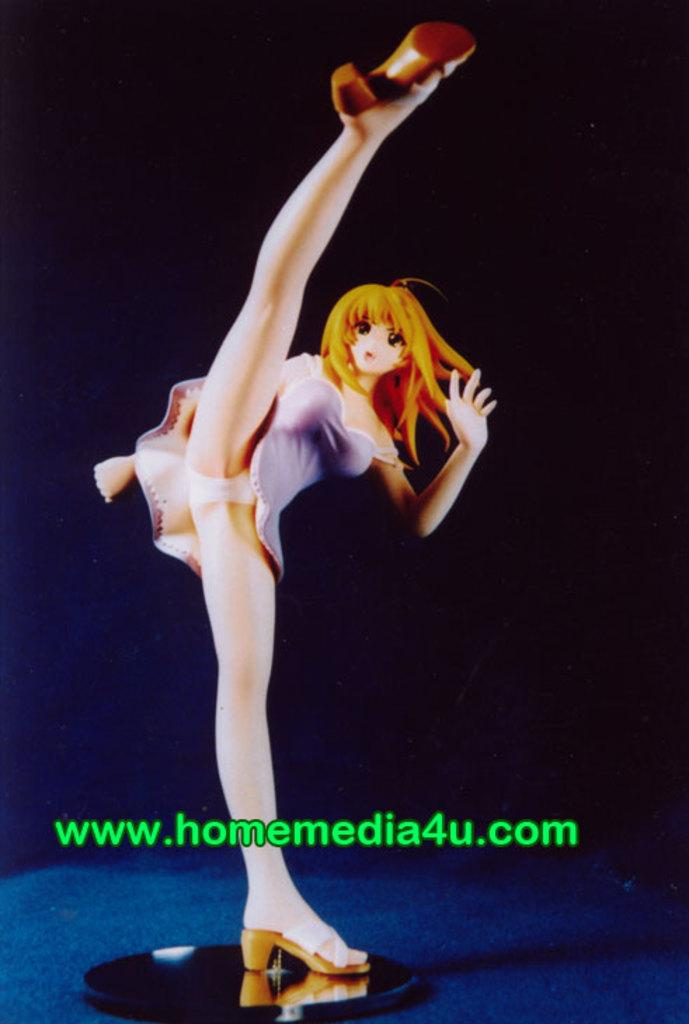What can be seen in the image besides the background? There is a toy in the image, which is on an object. Can you describe the object the toy is on? The object is on a surface. How would you describe the overall appearance of the image? The background of the image is dark. Is there any additional marking or feature on the image? Yes, there is a watermark on the image. What type of paper is the toy resting on in the image? There is no paper present in the image; the toy is on an object that is on a surface. Can you see any teeth or dental work in the image? There are no teeth or dental work visible in the image. 